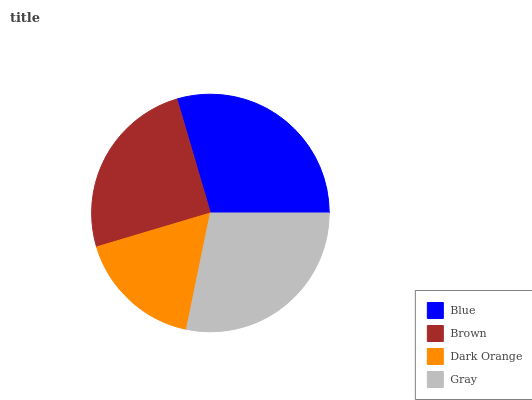Is Dark Orange the minimum?
Answer yes or no. Yes. Is Blue the maximum?
Answer yes or no. Yes. Is Brown the minimum?
Answer yes or no. No. Is Brown the maximum?
Answer yes or no. No. Is Blue greater than Brown?
Answer yes or no. Yes. Is Brown less than Blue?
Answer yes or no. Yes. Is Brown greater than Blue?
Answer yes or no. No. Is Blue less than Brown?
Answer yes or no. No. Is Gray the high median?
Answer yes or no. Yes. Is Brown the low median?
Answer yes or no. Yes. Is Dark Orange the high median?
Answer yes or no. No. Is Blue the low median?
Answer yes or no. No. 